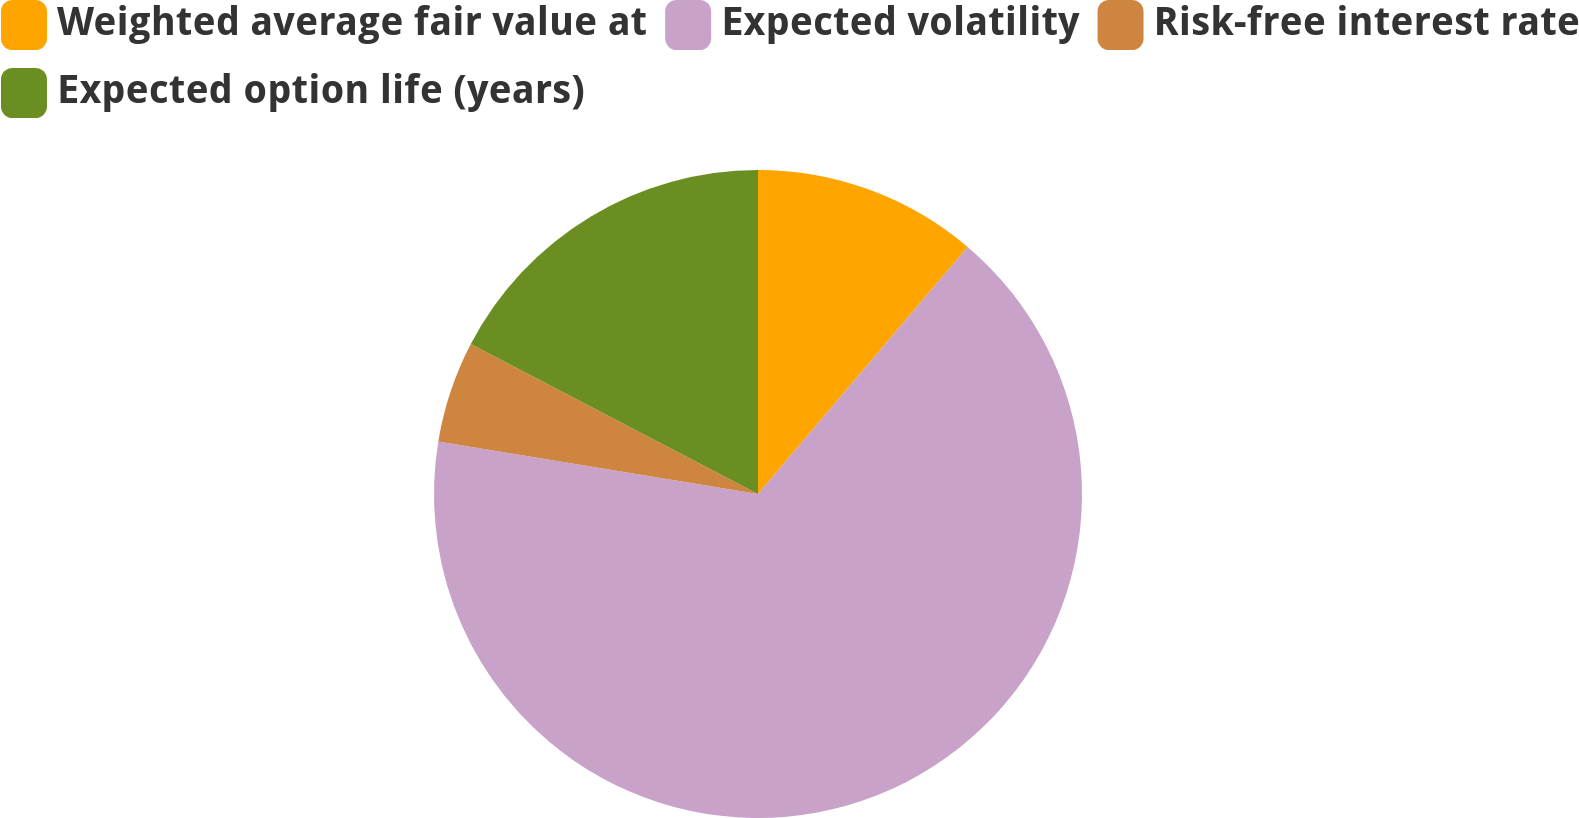Convert chart. <chart><loc_0><loc_0><loc_500><loc_500><pie_chart><fcel>Weighted average fair value at<fcel>Expected volatility<fcel>Risk-free interest rate<fcel>Expected option life (years)<nl><fcel>11.2%<fcel>66.39%<fcel>5.07%<fcel>17.34%<nl></chart> 